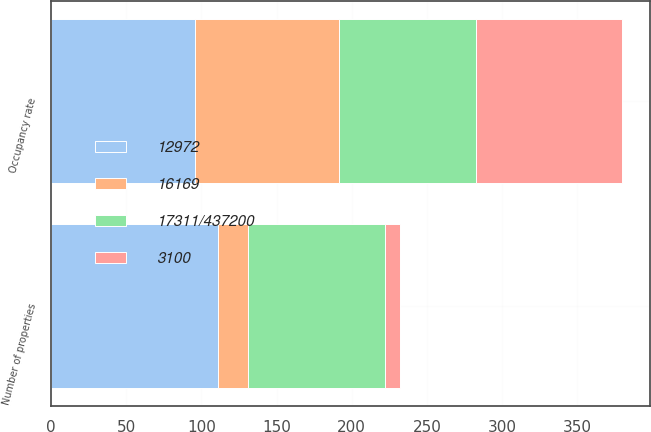Convert chart to OTSL. <chart><loc_0><loc_0><loc_500><loc_500><stacked_bar_chart><ecel><fcel>Number of properties<fcel>Occupancy rate<nl><fcel>16169<fcel>20<fcel>96<nl><fcel>17311/437200<fcel>91<fcel>91.2<nl><fcel>12972<fcel>111<fcel>95.6<nl><fcel>3100<fcel>10<fcel>97<nl></chart> 